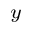<formula> <loc_0><loc_0><loc_500><loc_500>_ { y }</formula> 